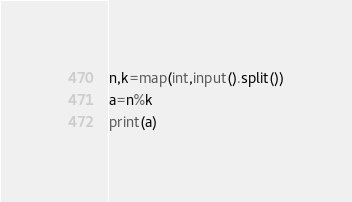Convert code to text. <code><loc_0><loc_0><loc_500><loc_500><_Python_>n,k=map(int,input().split())
a=n%k
print(a)</code> 